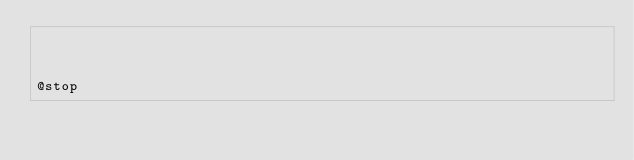Convert code to text. <code><loc_0><loc_0><loc_500><loc_500><_PHP_>


@stop</code> 